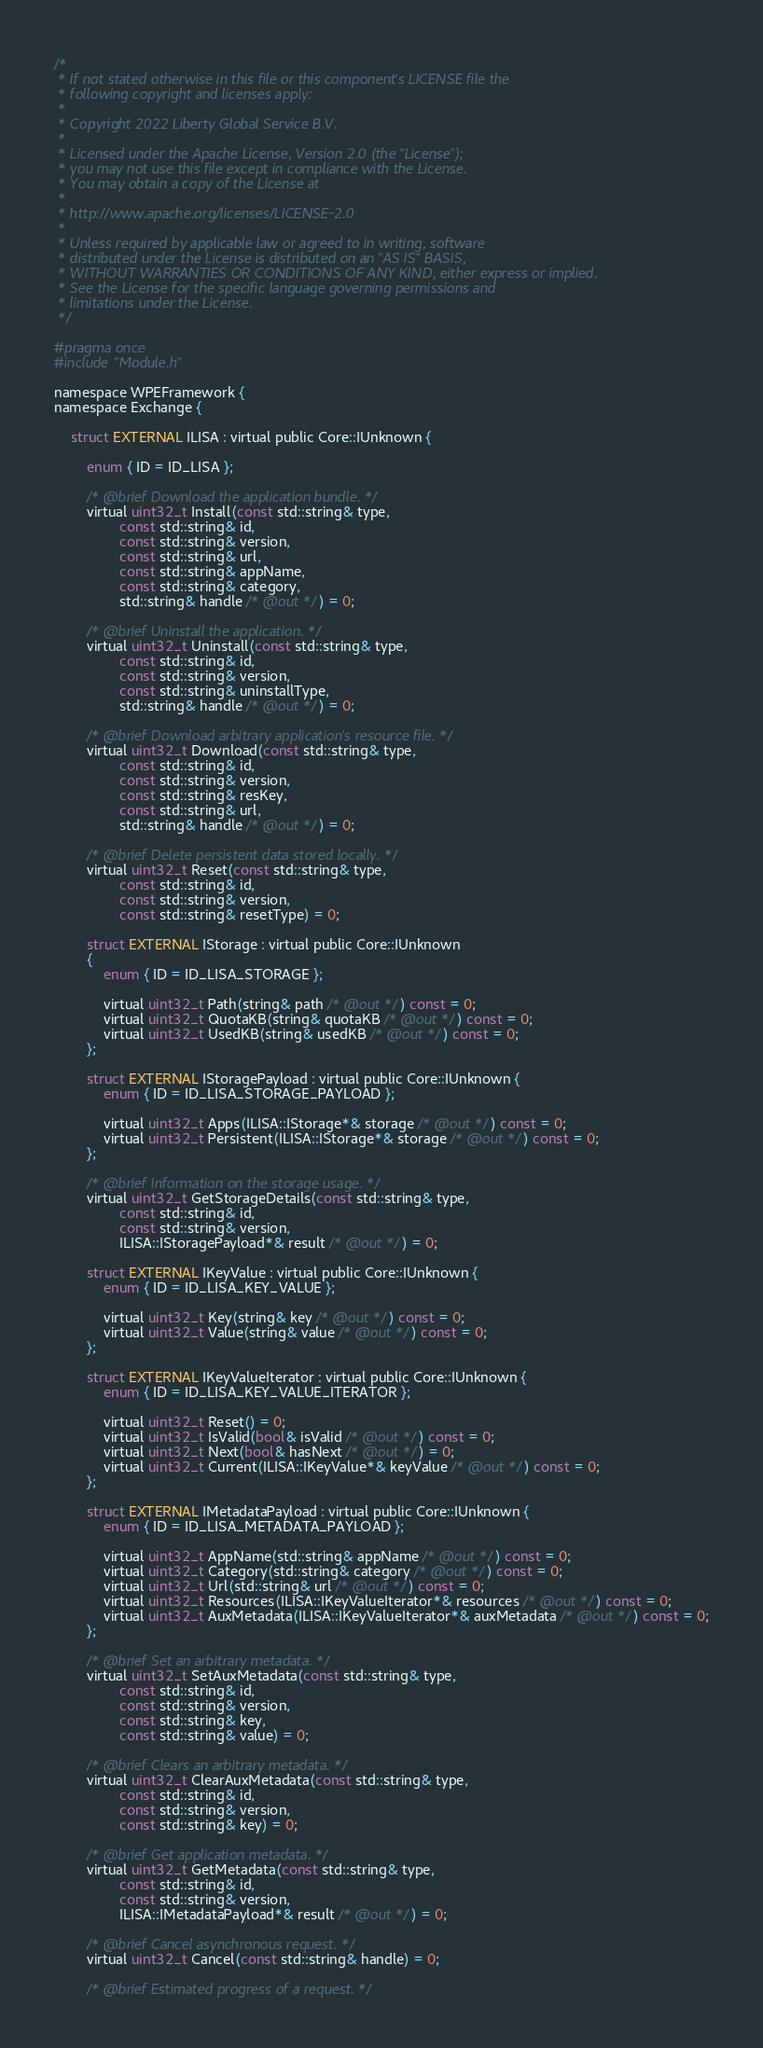Convert code to text. <code><loc_0><loc_0><loc_500><loc_500><_C_>/*
 * If not stated otherwise in this file or this component's LICENSE file the
 * following copyright and licenses apply:
 *
 * Copyright 2022 Liberty Global Service B.V.
 *
 * Licensed under the Apache License, Version 2.0 (the "License");
 * you may not use this file except in compliance with the License.
 * You may obtain a copy of the License at
 *
 * http://www.apache.org/licenses/LICENSE-2.0
 *
 * Unless required by applicable law or agreed to in writing, software
 * distributed under the License is distributed on an "AS IS" BASIS,
 * WITHOUT WARRANTIES OR CONDITIONS OF ANY KIND, either express or implied.
 * See the License for the specific language governing permissions and
 * limitations under the License.
 */

#pragma once
#include "Module.h"

namespace WPEFramework {
namespace Exchange {

    struct EXTERNAL ILISA : virtual public Core::IUnknown {

        enum { ID = ID_LISA };

        /* @brief Download the application bundle. */
        virtual uint32_t Install(const std::string& type,
                const std::string& id,
                const std::string& version,
                const std::string& url,
                const std::string& appName,
                const std::string& category,
                std::string& handle /* @out */) = 0;

        /* @brief Uninstall the application. */
        virtual uint32_t Uninstall(const std::string& type,
                const std::string& id,
                const std::string& version,
                const std::string& uninstallType,
                std::string& handle /* @out */) = 0;

        /* @brief Download arbitrary application's resource file. */
        virtual uint32_t Download(const std::string& type,
                const std::string& id,
                const std::string& version,
                const std::string& resKey,
                const std::string& url,
                std::string& handle /* @out */) = 0;

        /* @brief Delete persistent data stored locally. */
        virtual uint32_t Reset(const std::string& type,
                const std::string& id,
                const std::string& version,
                const std::string& resetType) = 0;

        struct EXTERNAL IStorage : virtual public Core::IUnknown
        {
            enum { ID = ID_LISA_STORAGE };

            virtual uint32_t Path(string& path /* @out */) const = 0;
            virtual uint32_t QuotaKB(string& quotaKB /* @out */) const = 0;
            virtual uint32_t UsedKB(string& usedKB /* @out */) const = 0;
        };

        struct EXTERNAL IStoragePayload : virtual public Core::IUnknown {
            enum { ID = ID_LISA_STORAGE_PAYLOAD };

            virtual uint32_t Apps(ILISA::IStorage*& storage /* @out */) const = 0;
            virtual uint32_t Persistent(ILISA::IStorage*& storage /* @out */) const = 0;
        };

        /* @brief Information on the storage usage. */
        virtual uint32_t GetStorageDetails(const std::string& type,
                const std::string& id,
                const std::string& version,
                ILISA::IStoragePayload*& result /* @out */) = 0;

        struct EXTERNAL IKeyValue : virtual public Core::IUnknown {
            enum { ID = ID_LISA_KEY_VALUE };

            virtual uint32_t Key(string& key /* @out */) const = 0;
            virtual uint32_t Value(string& value /* @out */) const = 0;
        };

        struct EXTERNAL IKeyValueIterator : virtual public Core::IUnknown {
            enum { ID = ID_LISA_KEY_VALUE_ITERATOR };

            virtual uint32_t Reset() = 0;
            virtual uint32_t IsValid(bool& isValid /* @out */) const = 0;
            virtual uint32_t Next(bool& hasNext /* @out */) = 0;
            virtual uint32_t Current(ILISA::IKeyValue*& keyValue /* @out */) const = 0;
        };

        struct EXTERNAL IMetadataPayload : virtual public Core::IUnknown {
            enum { ID = ID_LISA_METADATA_PAYLOAD };

            virtual uint32_t AppName(std::string& appName /* @out */) const = 0;
            virtual uint32_t Category(std::string& category /* @out */) const = 0;
            virtual uint32_t Url(std::string& url /* @out */) const = 0;
            virtual uint32_t Resources(ILISA::IKeyValueIterator*& resources /* @out */) const = 0;
            virtual uint32_t AuxMetadata(ILISA::IKeyValueIterator*& auxMetadata /* @out */) const = 0;
        };

        /* @brief Set an arbitrary metadata. */
        virtual uint32_t SetAuxMetadata(const std::string& type,
                const std::string& id,
                const std::string& version,
                const std::string& key,
                const std::string& value) = 0;

        /* @brief Clears an arbitrary metadata. */
        virtual uint32_t ClearAuxMetadata(const std::string& type,
                const std::string& id,
                const std::string& version,
                const std::string& key) = 0;

        /* @brief Get application metadata. */
        virtual uint32_t GetMetadata(const std::string& type,
                const std::string& id,
                const std::string& version,
                ILISA::IMetadataPayload*& result /* @out */) = 0;

        /* @brief Cancel asynchronous request. */
        virtual uint32_t Cancel(const std::string& handle) = 0;

        /* @brief Estimated progress of a request. */</code> 